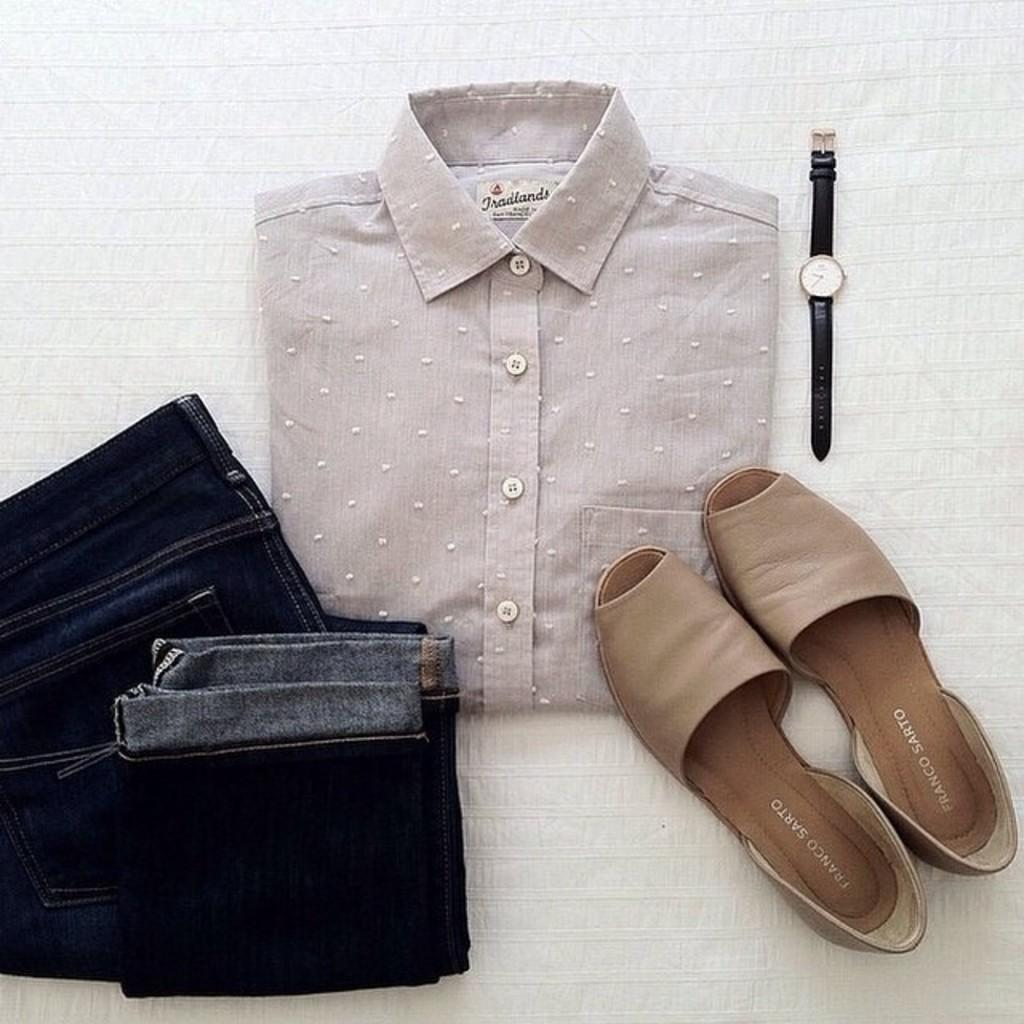What type of clothing items are visible in the image? There is a shirt and a pant in the image. What type of footwear is present in the image? There are chappals in the image. What accessory is visible in the image? There is a watch in the image. What type of expert advice can be seen in the image? There is no expert advice present in the image; it features clothing items, footwear, and a watch. Is there a tent visible in the image? No, there is no tent present in the image. 